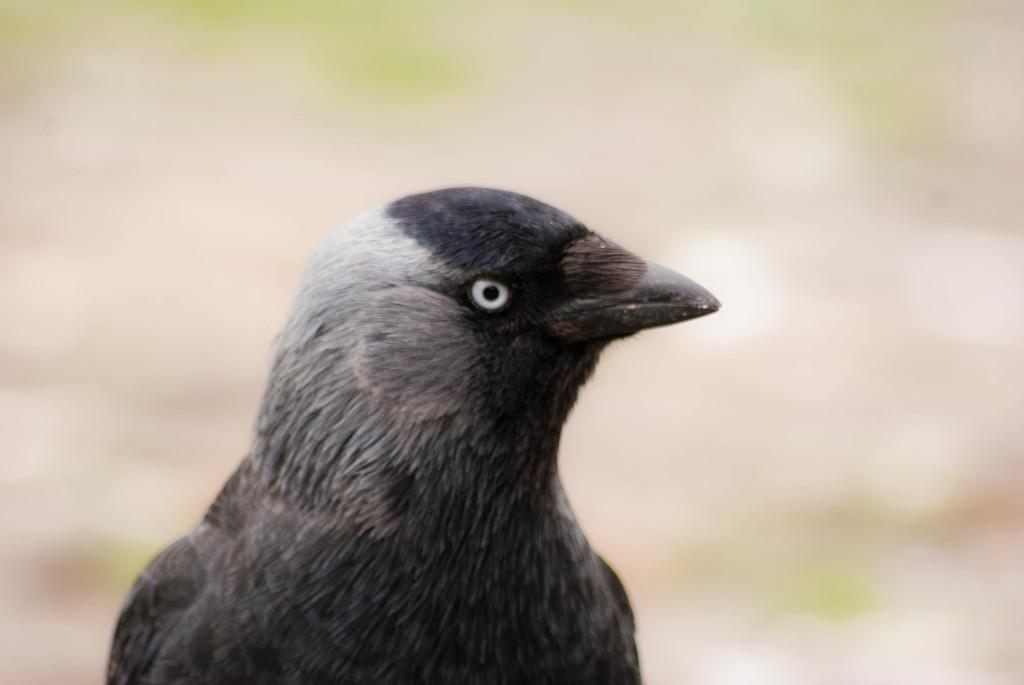What type of animal is present in the image? There is a bird in the image. Can you describe the color of the bird? The bird is in black and gray color. What type of home does the bird live in within the image? There is no information about the bird's home in the image. 